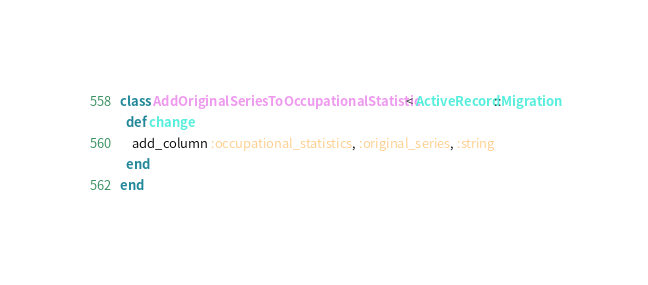Convert code to text. <code><loc_0><loc_0><loc_500><loc_500><_Ruby_>class AddOriginalSeriesToOccupationalStatistic < ActiveRecord::Migration
  def change
    add_column :occupational_statistics, :original_series, :string
  end
end
</code> 